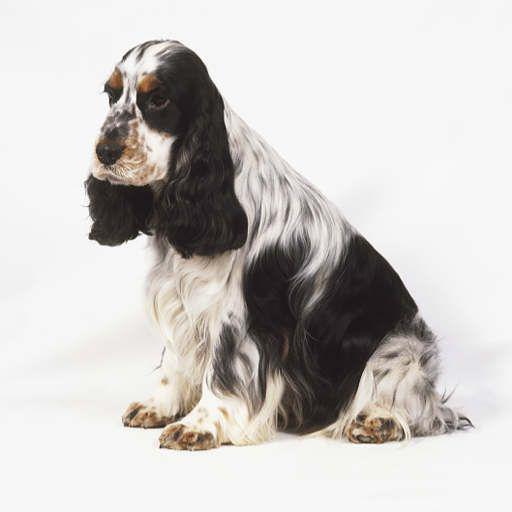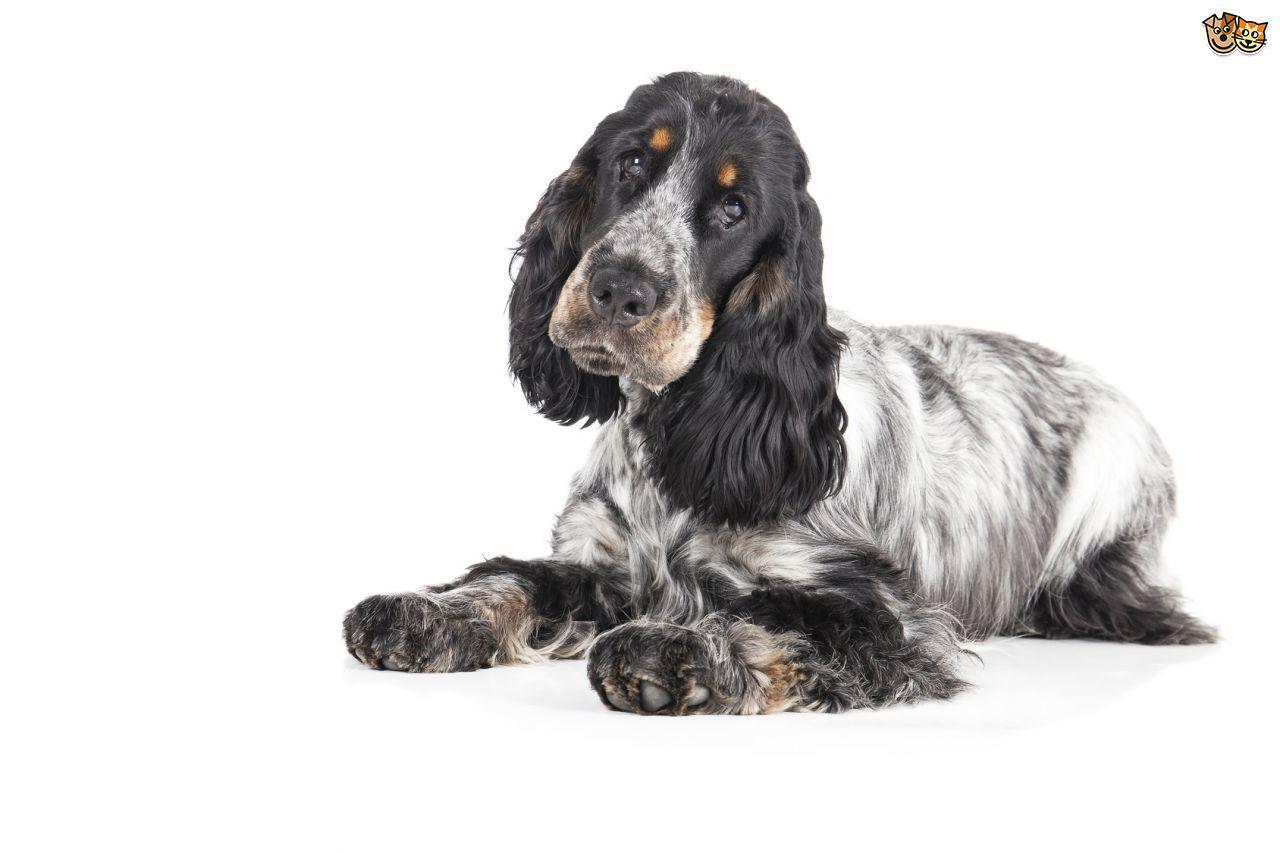The first image is the image on the left, the second image is the image on the right. Analyze the images presented: Is the assertion "One dog is not in a sitting position." valid? Answer yes or no. Yes. The first image is the image on the left, the second image is the image on the right. Examine the images to the left and right. Is the description "Left image features one dog sitting with head and body turned leftward." accurate? Answer yes or no. Yes. 